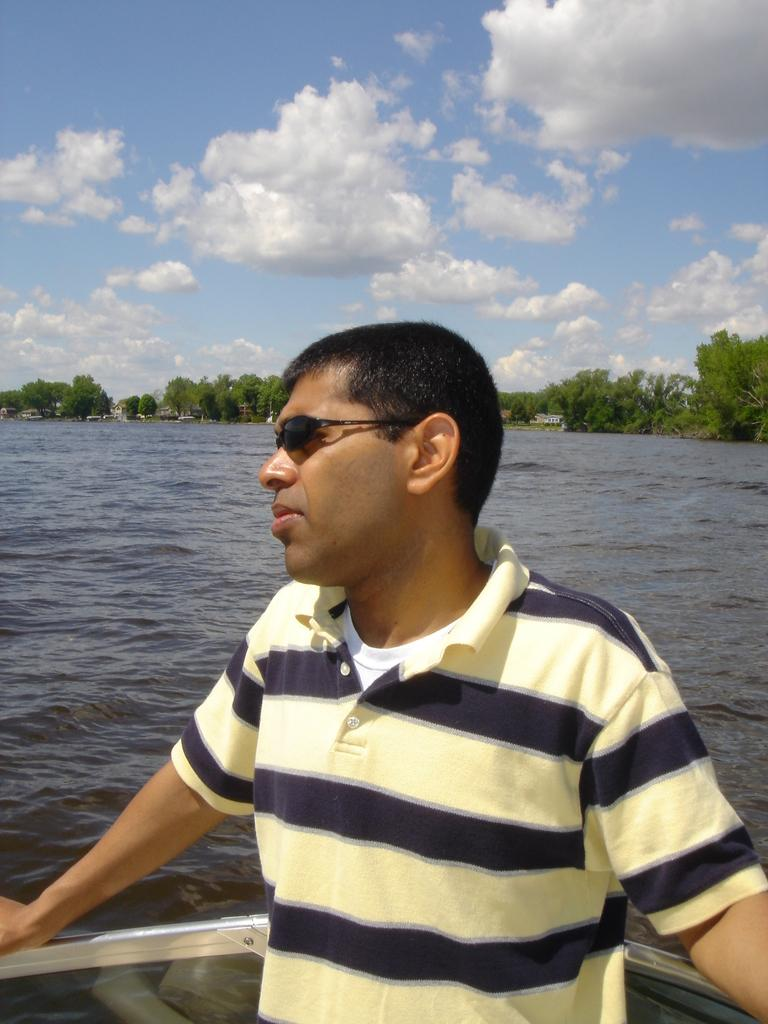What is the main subject in the image? There is a person standing in the image. What type of natural environment is visible in the image? There are many trees and a sea in the image. How would you describe the sky in the image? The sky is blue and cloudy in the image. Where is the office located in the image? There is no office present in the image. Is there an argument taking place between the trees in the image? There is no argument present in the image; it only shows trees and a person standing. 